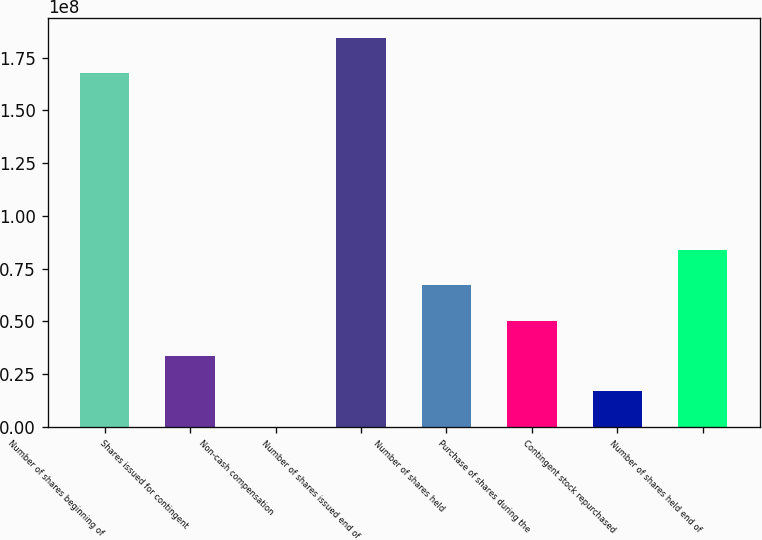<chart> <loc_0><loc_0><loc_500><loc_500><bar_chart><fcel>Number of shares beginning of<fcel>Shares issued for contingent<fcel>Non-cash compensation<fcel>Number of shares issued end of<fcel>Number of shares held<fcel>Purchase of shares during the<fcel>Contingent stock repurchased<fcel>Number of shares held end of<nl><fcel>1.67742e+08<fcel>3.36299e+07<fcel>9394<fcel>1.84552e+08<fcel>6.72504e+07<fcel>5.04401e+07<fcel>1.68196e+07<fcel>8.40606e+07<nl></chart> 